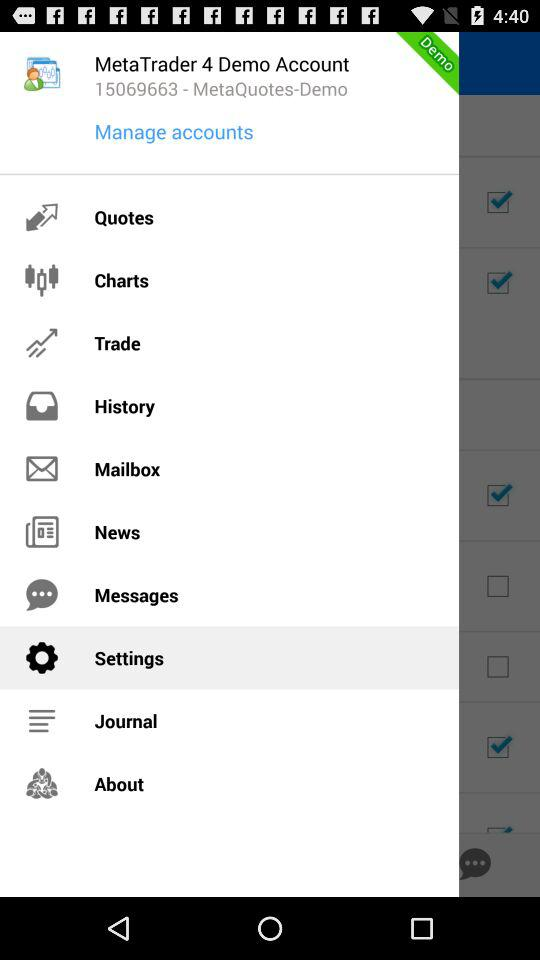What's the selected item in the menu? The selected item in the menu is "Settings". 